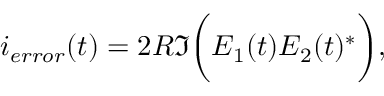<formula> <loc_0><loc_0><loc_500><loc_500>i _ { e r r o r } ( t ) = 2 R \Im \left ( E _ { 1 } ( t ) E _ { 2 } ( t ) ^ { * } \right ) ,</formula> 